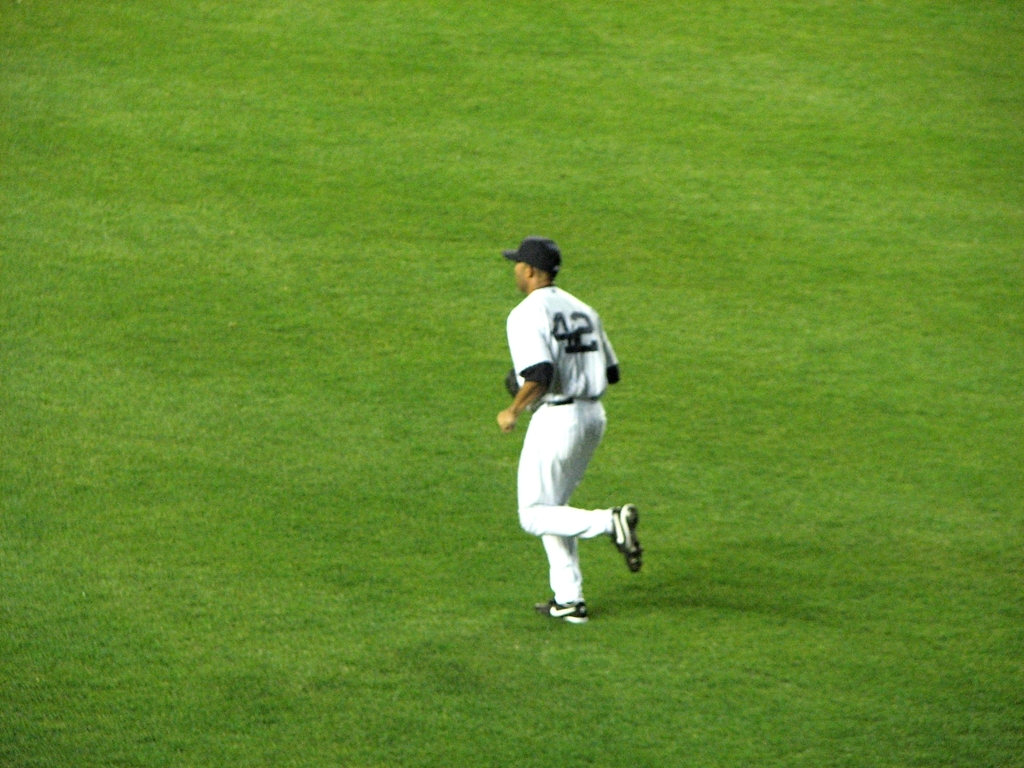Is the background grassland relatively clean?
A. Yes
B. No
Answer with the option's letter from the given choices directly. A. Yes, the grassland in the background appears to be well-maintained and free of noticeable litter or debris, which suggests the area is kept clean. 